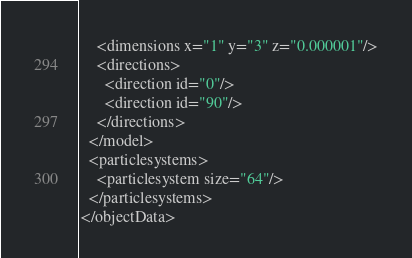<code> <loc_0><loc_0><loc_500><loc_500><_XML_>    <dimensions x="1" y="3" z="0.000001"/>
    <directions>
      <direction id="0"/>
      <direction id="90"/>
    </directions>
  </model>
  <particlesystems>
    <particlesystem size="64"/>
  </particlesystems>
</objectData></code> 